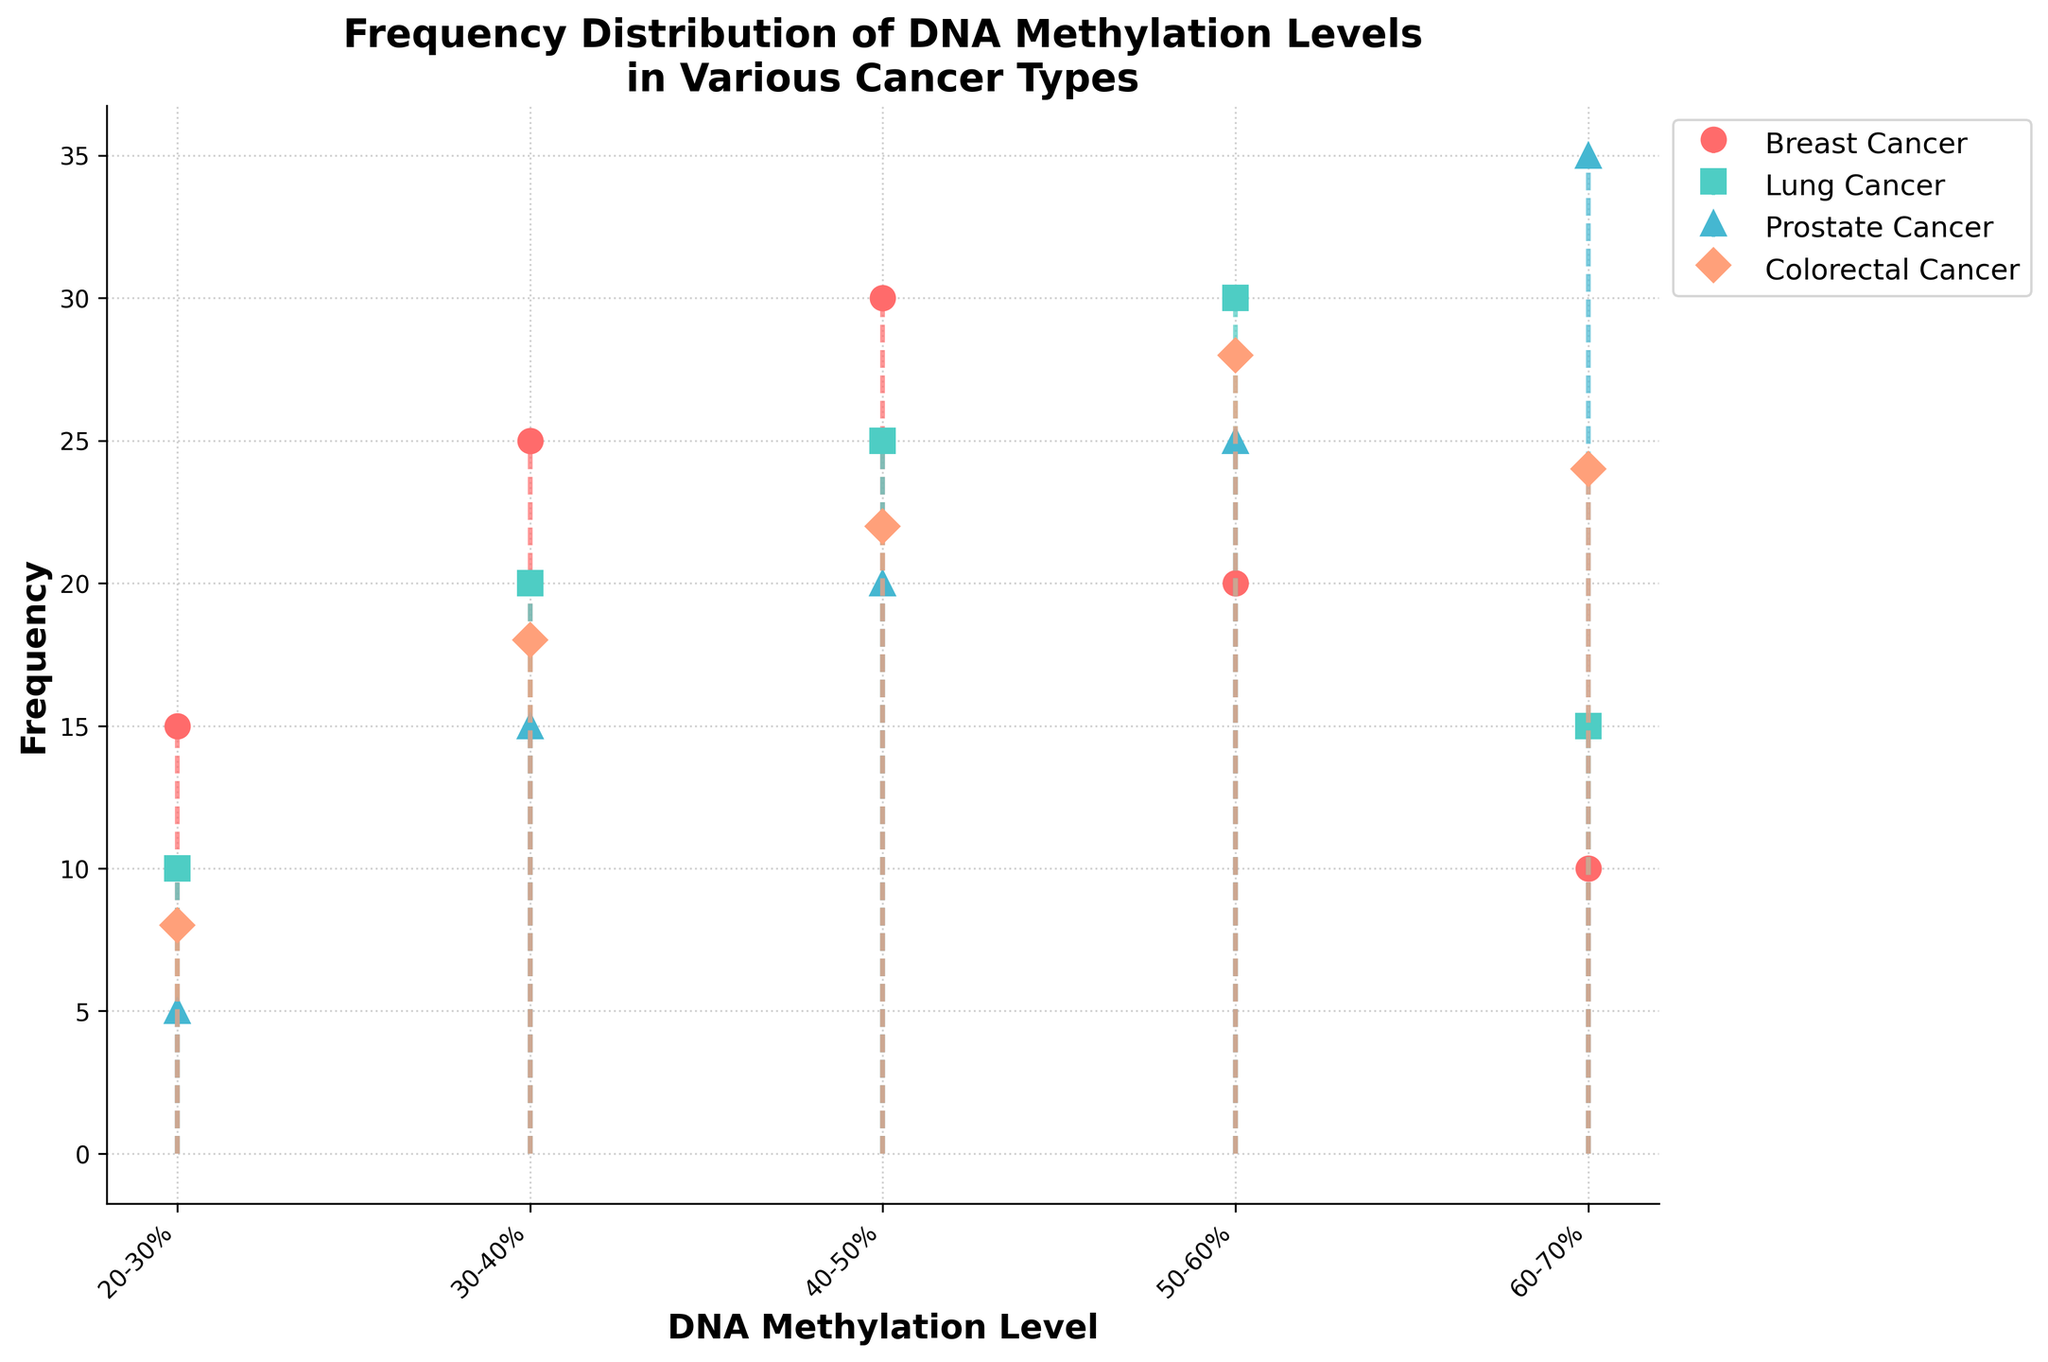What is the title of the figure? The title is located at the top of the figure and describes its content. It summarizes the type of data and the context.
Answer: Frequency Distribution of DNA Methylation Levels in Various Cancer Types How are the DNA methylation levels labeled on the x-axis? The x-axis represents the different ranges of DNA methylation levels. Each label corresponds to a specific percentage range of methylation levels.
Answer: 20-30%, 30-40%, 40-50%, 50-60%, 60-70% Which cancer type has the highest frequency at the 60-70% DNA methylation level? Among the stem plots, identify the height of the stems at the 60-70% DNA methylation level for each cancer type and determine the tallest one.
Answer: Prostate Cancer Which cancer type shows the most uniform distribution across the DNA methylation levels? Analyze the heights of the stems for each cancer type across the different methylation levels and look for the type with relatively equal stem heights.
Answer: Colorectal Cancer What is the frequency of Breast Cancer cells in the 50-60% DNA methylation level range? Locate the 50-60% DNA methylation level on the x-axis and identify the height of the corresponding stem for Breast Cancer.
Answer: 20 Compare the frequency of Lung Cancer and Prostate Cancer at the 40-50% DNA methylation level. Which one is higher and by how much? Locate the stems for Lung Cancer and Prostate Cancer at the 40-50% level and compare their heights. Calculate the difference.
Answer: Prostate Cancer is higher by 5 What is the average frequency of DNA methylation levels for Colorectal Cancer? Add up the frequencies for Colorectal Cancer across all DNA methylation levels and divide by the total number of levels (5). (8+18+22+28+24)/5 = 100/5
Answer: 20 Which cancer type has the steepest increase in frequency from one DNA methylation level to the next? Look for the cancer type that shows the largest difference in stem heights between adjacent DNA methylation levels.
Answer: Breast Cancer from 30-40% to 40-50% What is the overall trend in the frequency of DNA methylation levels for Lung Cancer as the methylation percentage increases? Observe the general pattern of stem heights for Lung Cancer from lowest to highest DNA methylation levels.
Answer: Increasing then decreasing Are there any cancer types that show a decreasing trend in frequency with increasing DNA methylation levels? Examine each cancer type for a pattern where the stem heights consistently decrease as the DNA methylation levels increase.
Answer: Breast Cancer 